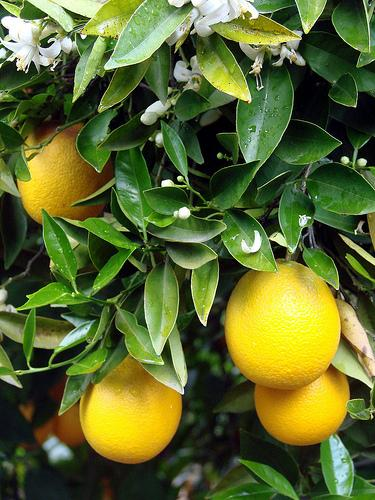Count the total number of oranges in the image. There are five oranges in the image. What type of vegetation is depicted in the image? A lemon tree with green leaves, yellow fruits, and white flowers is depicted in the image. Mention the condition of one of the leaves in the image. One of the leaves is yellowing in the image. Identify a distinguishing property of one of the leaves in the image. One of the leaves has water droplets on its surface. Explain the interaction between the white petals and the green leaves in the image. White petals can be seen resting on the green leaves in the image. Identify the primary object in the image and its color. The primary object is lemons, and they are yellow in color. Describe the texture of one of the orange fruits in the image. The texture of the orange fruit is porous. What is a notable feature of the white flowers in the image? The white flowers have both blooming and budding stages in the image. How many lemons can be seen in the image? There are four lemons visible in the image. What is the color of the leaves on the tree in the image? The color of the leaves on the tree is green. How many lemons can you see in the image? four lemons Locate a leaf with a distinct appearance. Pointy leaf with drops of water What is surrounding the yellow fruits in the image? Green leaves Are there any water droplets on the leaves or fruits in the image? Yes, there are water droplets on both leaves and fruits. Which one of these statements best describes the scene: a) lemons in a tree with white flowers, b) oranges in a tree with purple flowers, or c) apples in a tree with no flowers? lemons in a tree with white flowers Can you find the cluster of red apples hanging from the tree?  There are no red apples mentioned in the list of objects; the objects are mainly about lemons and oranges. Where is the bluebird sitting on a branch in the tree?  There is no mention of a bluebird or any bird in the objects list, only plant-based items are mentioned. Which statement is true: a) There are no green leaves in the image, b) There are no water droplets in the image, or c) There are no white flowers in the image? None of them are true. Are there any oranges in the image? No, there are no oranges, only lemons. What fruit is most prominent in this picture? Lemons Can you find a ripe red tomato hidden among the leaves? There is no mention of a tomato in the image, only oranges and lemons are listed as fruits. What is the texture of the fruit's peel? Porous Is there a white flower bud in the image? Yes, there is a white flower bud. What is the overall color theme of the image? Yellow, green, and white Could you point out the large purple flowers on the lemon tree?  There are no purple flowers in the objects list; the flowers are white flowers of a lemon tree. Are there any squirrels climbing on the tree branches? There are no squirrels or any animals mentioned in the objects list related to the image. Write a descriptive sentence about the leaves and flowers of the tree. Green leaves and white flowers adorn a lemon tree. Describe a unique feature you can see on one of the leaves. A curled tan leaf has black spots on it. Explain the appearance of the fruit hanging from the tree. The fruit is yellow and round, with some partially hidden by green leaves. What feature can be observed on the fruit's surface? Drops of water on the lemons Describe the scene with an emphasis on the color of the fruit and flowers. Yellow lemons hang from a tree surrounded by vibrant green leaves and delicate white flowers. Write a succinct description of the interaction between the fruit and the green leaves. Yellow lemons peek through a canopy of green leaves. Describe the fruit featured in the image. Yellow, rounded lemons hanging from a tree. Could you spot a person picking up oranges in the background? There is no mention of a person or any human-related object in the objects list. All listed objects are related to the tree and its fruits, leaves, and flowers. What kind of tree is depicted in the image? A lemon tree Spot the fruit with green leaves but without white flowers in close proximity. An orange-colored fruit with green leaves 